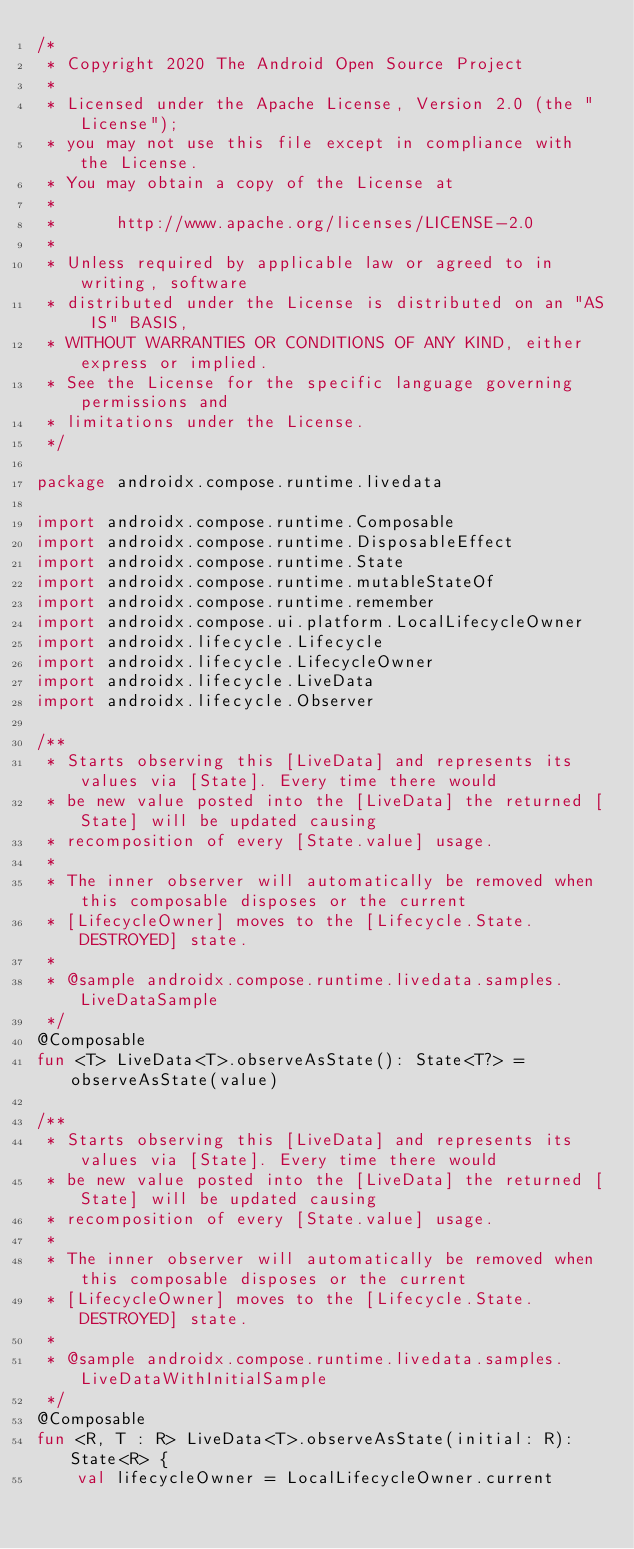<code> <loc_0><loc_0><loc_500><loc_500><_Kotlin_>/*
 * Copyright 2020 The Android Open Source Project
 *
 * Licensed under the Apache License, Version 2.0 (the "License");
 * you may not use this file except in compliance with the License.
 * You may obtain a copy of the License at
 *
 *      http://www.apache.org/licenses/LICENSE-2.0
 *
 * Unless required by applicable law or agreed to in writing, software
 * distributed under the License is distributed on an "AS IS" BASIS,
 * WITHOUT WARRANTIES OR CONDITIONS OF ANY KIND, either express or implied.
 * See the License for the specific language governing permissions and
 * limitations under the License.
 */

package androidx.compose.runtime.livedata

import androidx.compose.runtime.Composable
import androidx.compose.runtime.DisposableEffect
import androidx.compose.runtime.State
import androidx.compose.runtime.mutableStateOf
import androidx.compose.runtime.remember
import androidx.compose.ui.platform.LocalLifecycleOwner
import androidx.lifecycle.Lifecycle
import androidx.lifecycle.LifecycleOwner
import androidx.lifecycle.LiveData
import androidx.lifecycle.Observer

/**
 * Starts observing this [LiveData] and represents its values via [State]. Every time there would
 * be new value posted into the [LiveData] the returned [State] will be updated causing
 * recomposition of every [State.value] usage.
 *
 * The inner observer will automatically be removed when this composable disposes or the current
 * [LifecycleOwner] moves to the [Lifecycle.State.DESTROYED] state.
 *
 * @sample androidx.compose.runtime.livedata.samples.LiveDataSample
 */
@Composable
fun <T> LiveData<T>.observeAsState(): State<T?> = observeAsState(value)

/**
 * Starts observing this [LiveData] and represents its values via [State]. Every time there would
 * be new value posted into the [LiveData] the returned [State] will be updated causing
 * recomposition of every [State.value] usage.
 *
 * The inner observer will automatically be removed when this composable disposes or the current
 * [LifecycleOwner] moves to the [Lifecycle.State.DESTROYED] state.
 *
 * @sample androidx.compose.runtime.livedata.samples.LiveDataWithInitialSample
 */
@Composable
fun <R, T : R> LiveData<T>.observeAsState(initial: R): State<R> {
    val lifecycleOwner = LocalLifecycleOwner.current</code> 